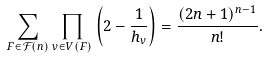<formula> <loc_0><loc_0><loc_500><loc_500>\sum _ { F \in \mathcal { F } ( n ) } \prod _ { v \in V ( F ) } \left ( 2 - \frac { 1 } { h _ { v } } \right ) = \frac { ( 2 n + 1 ) ^ { n - 1 } } { n ! } .</formula> 